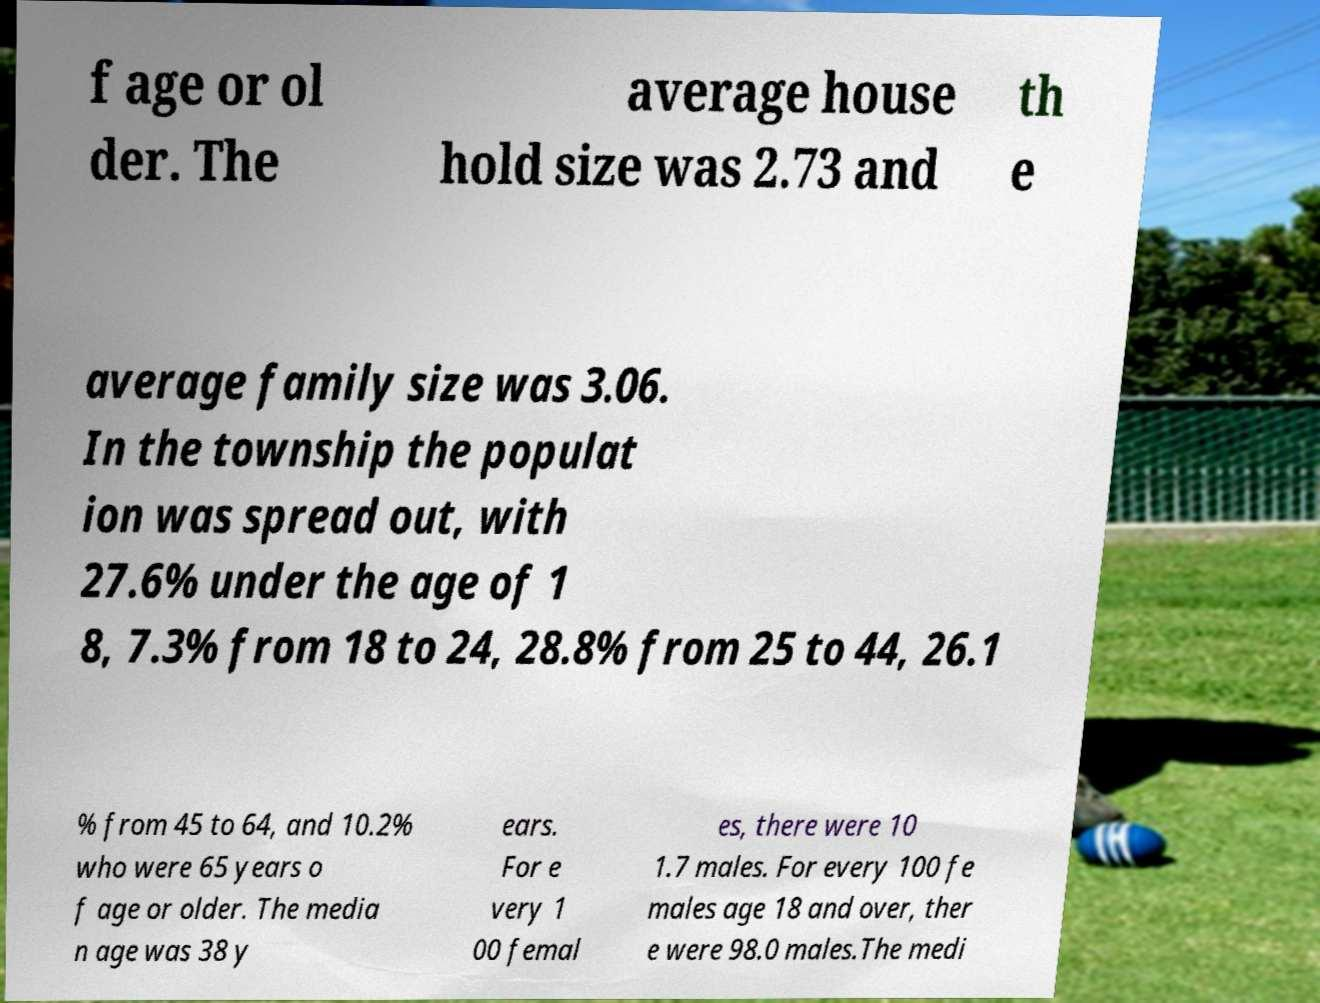For documentation purposes, I need the text within this image transcribed. Could you provide that? f age or ol der. The average house hold size was 2.73 and th e average family size was 3.06. In the township the populat ion was spread out, with 27.6% under the age of 1 8, 7.3% from 18 to 24, 28.8% from 25 to 44, 26.1 % from 45 to 64, and 10.2% who were 65 years o f age or older. The media n age was 38 y ears. For e very 1 00 femal es, there were 10 1.7 males. For every 100 fe males age 18 and over, ther e were 98.0 males.The medi 